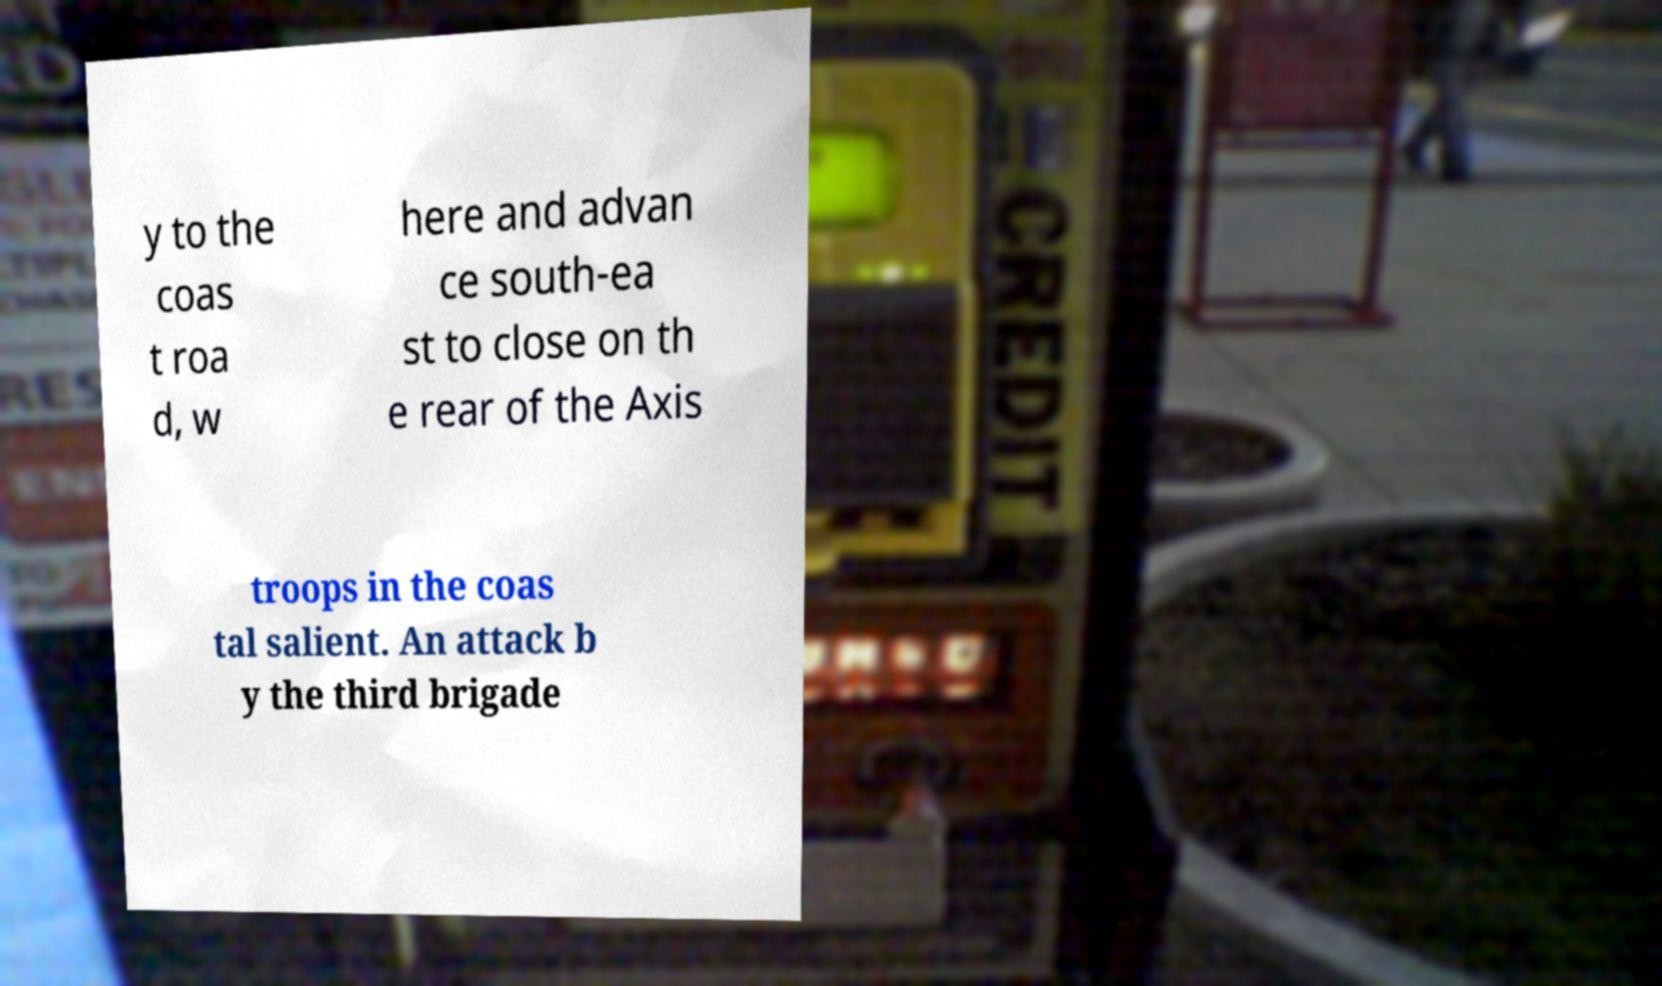What messages or text are displayed in this image? I need them in a readable, typed format. y to the coas t roa d, w here and advan ce south-ea st to close on th e rear of the Axis troops in the coas tal salient. An attack b y the third brigade 